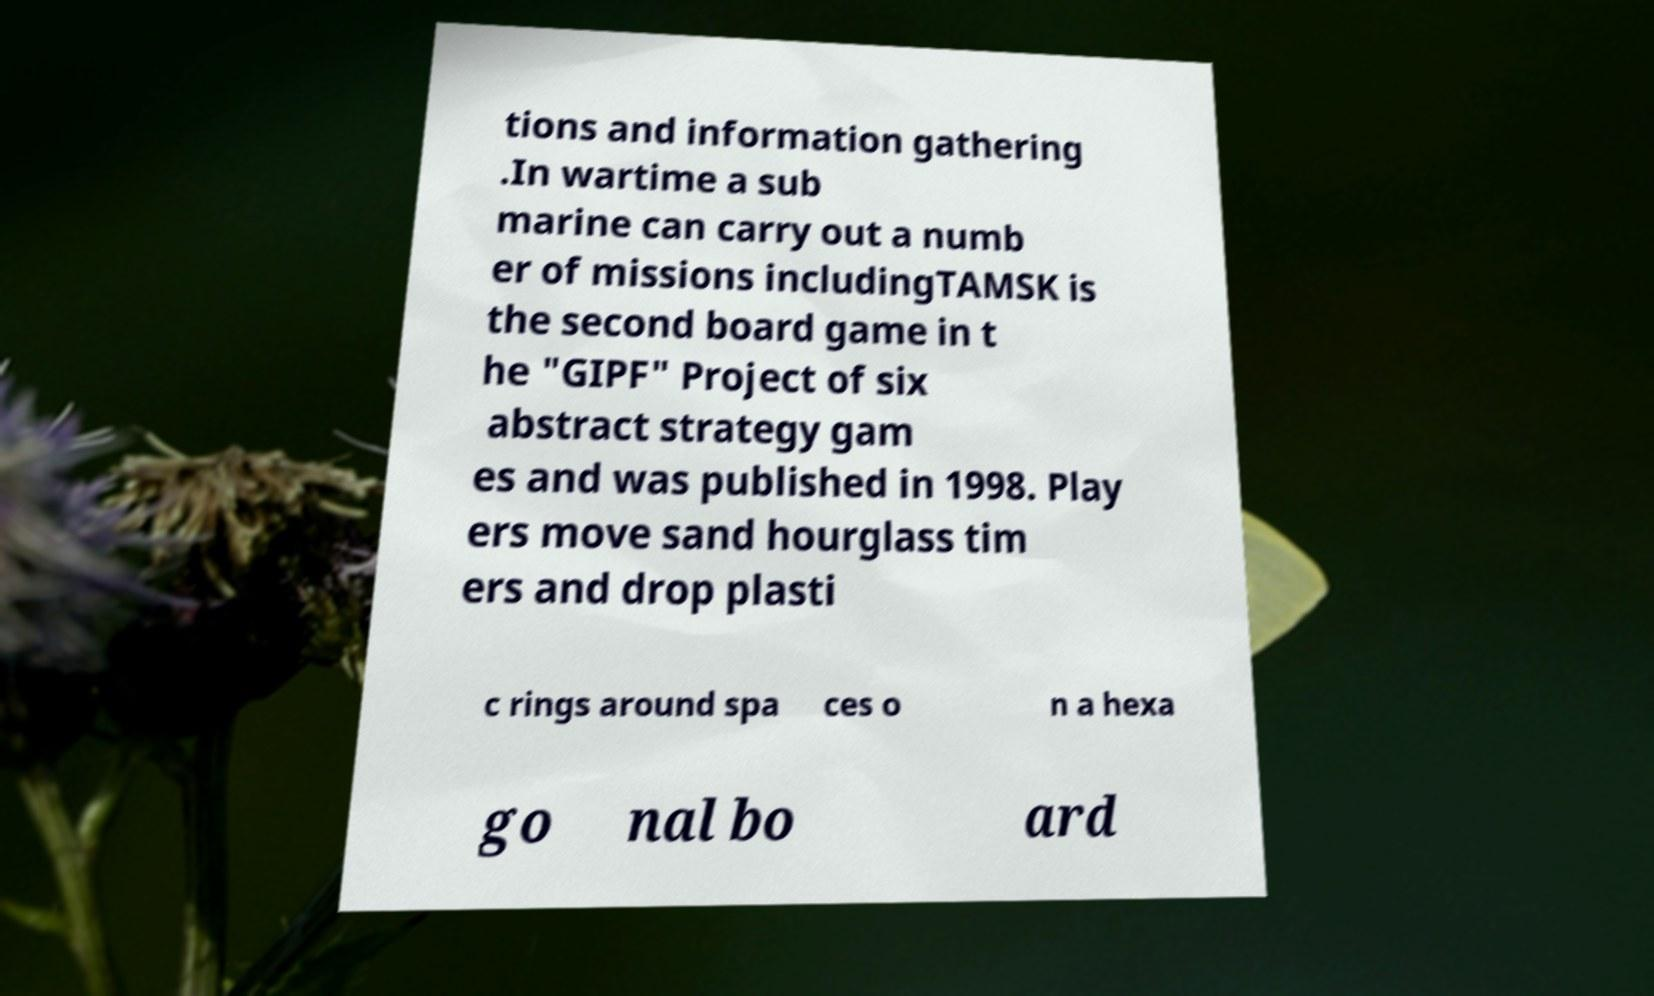There's text embedded in this image that I need extracted. Can you transcribe it verbatim? tions and information gathering .In wartime a sub marine can carry out a numb er of missions includingTAMSK is the second board game in t he "GIPF" Project of six abstract strategy gam es and was published in 1998. Play ers move sand hourglass tim ers and drop plasti c rings around spa ces o n a hexa go nal bo ard 